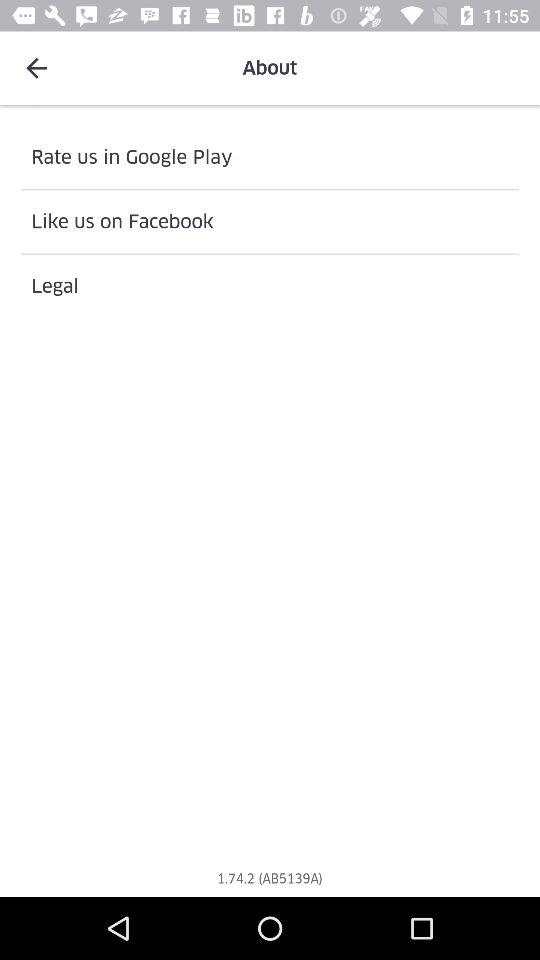For "Like", what application is used? The application is "Facebook". 